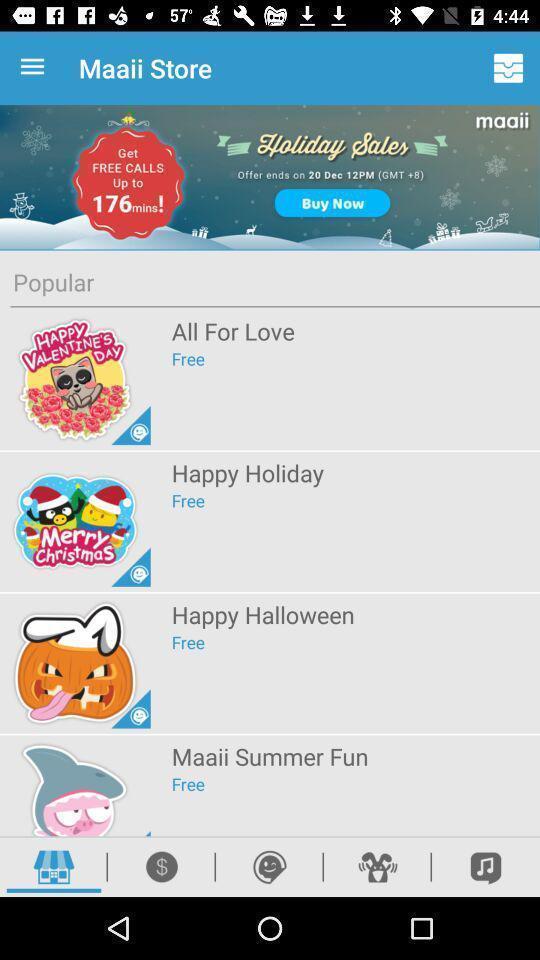Provide a description of this screenshot. Page showing theme options in a messaging app. 